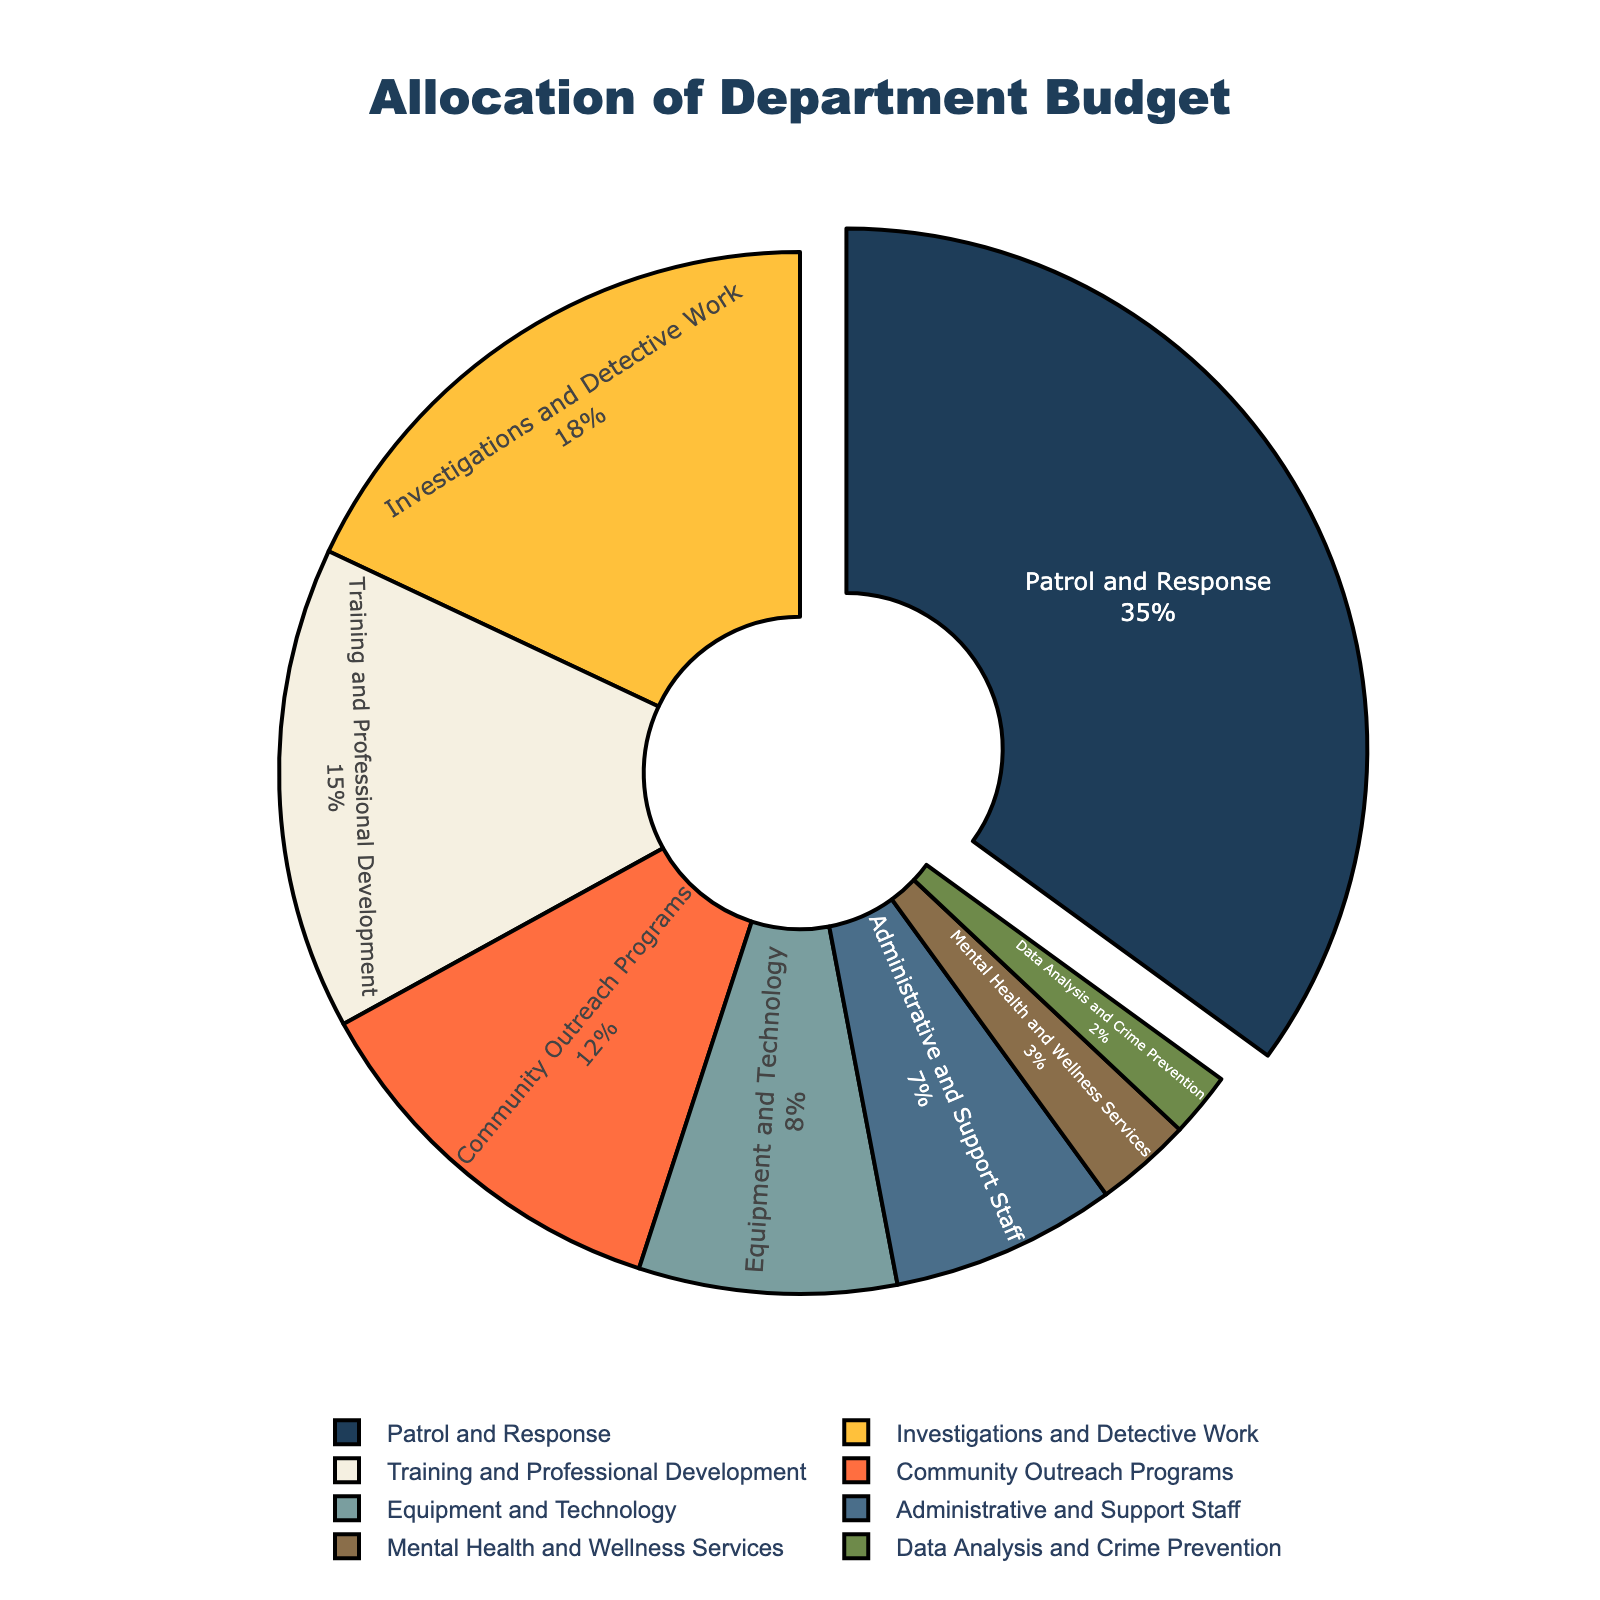What's the highest budget allocation category? The segment labeled "Patrol and Response" is the largest and is visually distinct by being pulled out from the rest of the pie chart.
Answer: Patrol and Response How much more percentage is allocated to Investigations and Detective Work compared to Equipment and Technology? The percentage for Investigations and Detective Work is 18%, while for Equipment and Technology, it is 8%. The difference is 18% - 8% = 10%.
Answer: 10% Which categories receive the smallest budget allocations? The smallest segments in the pie chart are labeled "Mental Health and Wellness Services" and "Data Analysis and Crime Prevention" with 3% and 2% respectively.
Answer: Mental Health and Wellness Services and Data Analysis and Crime Prevention What is the combined budget percentage for Training and Professional Development and Community Outreach Programs? The segment for Training and Professional Development is 15%, and for Community Outreach Programs, it is 12%. Combined, this is 15% + 12% = 27%.
Answer: 27% Which category has a higher budget allocation: Administrative and Support Staff or Community Outreach Programs? The segment for Community Outreach Programs is labeled with 12%, and the segment for Administrative and Support Staff is labeled with 7%. Since 12% is greater than 7%, Community Outreach Programs has a higher budget allocation.
Answer: Community Outreach Programs Are there any categories that have equal budget percentages? The pie chart segments are all uniquely labeled with individual percentages, and no two segments share the same percentage value.
Answer: No What is the difference in budget allocation between the highest and lowest categories? The highest percentage is for Patrol and Response at 35%, and the lowest is for Data Analysis and Crime Prevention at 2%. The difference is 35% - 2% = 33%.
Answer: 33% What percentage of the budget is allocated to non-response operations (everything except Patrol and Response)? The total budget is allocated 100%, with Patrol and Response taking 35%. The remaining percentage is 100% - 35% = 65%.
Answer: 65% How many categories have a budget allocation that is greater than or equal to 10%? The categories with 35%, 15%, 12%, and 18% all meet the criterion. Counting these, there are 4 categories.
Answer: 4 Is more budget allocated to Training and Professional Development or Investigations and Detective Work? The segment for Training and Professional Development is labeled with 15%, and the segment for Investigations and Detective Work is labeled with 18%. Since 18% is greater than 15%, Investigations and Detective Work has more budget.
Answer: Investigations and Detective Work 